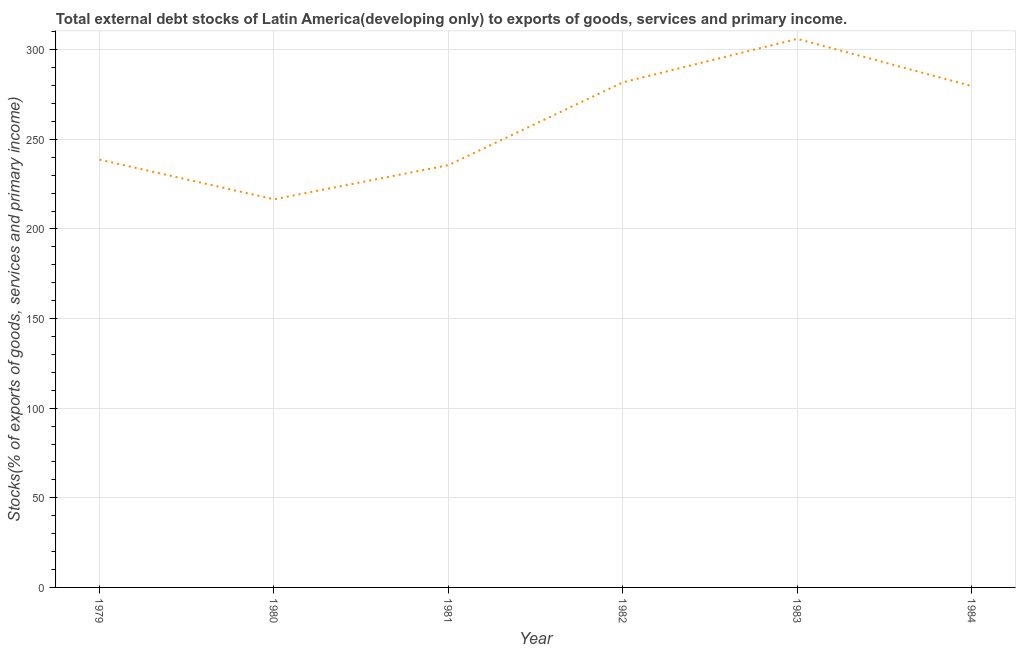What is the external debt stocks in 1981?
Offer a very short reply. 235.61. Across all years, what is the maximum external debt stocks?
Ensure brevity in your answer.  306.06. Across all years, what is the minimum external debt stocks?
Make the answer very short. 216.55. What is the sum of the external debt stocks?
Your answer should be very brief. 1558.36. What is the difference between the external debt stocks in 1980 and 1983?
Keep it short and to the point. -89.51. What is the average external debt stocks per year?
Your answer should be very brief. 259.73. What is the median external debt stocks?
Your response must be concise. 259.17. In how many years, is the external debt stocks greater than 60 %?
Keep it short and to the point. 6. What is the ratio of the external debt stocks in 1982 to that in 1984?
Offer a terse response. 1.01. Is the difference between the external debt stocks in 1983 and 1984 greater than the difference between any two years?
Offer a very short reply. No. What is the difference between the highest and the second highest external debt stocks?
Offer a terse response. 24.26. Is the sum of the external debt stocks in 1979 and 1984 greater than the maximum external debt stocks across all years?
Provide a short and direct response. Yes. What is the difference between the highest and the lowest external debt stocks?
Provide a succinct answer. 89.51. Does the external debt stocks monotonically increase over the years?
Make the answer very short. No. What is the difference between two consecutive major ticks on the Y-axis?
Offer a terse response. 50. Does the graph contain grids?
Offer a very short reply. Yes. What is the title of the graph?
Make the answer very short. Total external debt stocks of Latin America(developing only) to exports of goods, services and primary income. What is the label or title of the X-axis?
Give a very brief answer. Year. What is the label or title of the Y-axis?
Your response must be concise. Stocks(% of exports of goods, services and primary income). What is the Stocks(% of exports of goods, services and primary income) in 1979?
Give a very brief answer. 238.68. What is the Stocks(% of exports of goods, services and primary income) of 1980?
Your answer should be compact. 216.55. What is the Stocks(% of exports of goods, services and primary income) in 1981?
Your response must be concise. 235.61. What is the Stocks(% of exports of goods, services and primary income) of 1982?
Keep it short and to the point. 281.8. What is the Stocks(% of exports of goods, services and primary income) in 1983?
Provide a short and direct response. 306.06. What is the Stocks(% of exports of goods, services and primary income) of 1984?
Your response must be concise. 279.67. What is the difference between the Stocks(% of exports of goods, services and primary income) in 1979 and 1980?
Provide a succinct answer. 22.13. What is the difference between the Stocks(% of exports of goods, services and primary income) in 1979 and 1981?
Your answer should be compact. 3.08. What is the difference between the Stocks(% of exports of goods, services and primary income) in 1979 and 1982?
Your answer should be very brief. -43.12. What is the difference between the Stocks(% of exports of goods, services and primary income) in 1979 and 1983?
Make the answer very short. -67.38. What is the difference between the Stocks(% of exports of goods, services and primary income) in 1979 and 1984?
Your response must be concise. -40.99. What is the difference between the Stocks(% of exports of goods, services and primary income) in 1980 and 1981?
Provide a short and direct response. -19.06. What is the difference between the Stocks(% of exports of goods, services and primary income) in 1980 and 1982?
Your answer should be compact. -65.25. What is the difference between the Stocks(% of exports of goods, services and primary income) in 1980 and 1983?
Make the answer very short. -89.51. What is the difference between the Stocks(% of exports of goods, services and primary income) in 1980 and 1984?
Your answer should be very brief. -63.12. What is the difference between the Stocks(% of exports of goods, services and primary income) in 1981 and 1982?
Offer a very short reply. -46.19. What is the difference between the Stocks(% of exports of goods, services and primary income) in 1981 and 1983?
Your answer should be compact. -70.45. What is the difference between the Stocks(% of exports of goods, services and primary income) in 1981 and 1984?
Ensure brevity in your answer.  -44.06. What is the difference between the Stocks(% of exports of goods, services and primary income) in 1982 and 1983?
Give a very brief answer. -24.26. What is the difference between the Stocks(% of exports of goods, services and primary income) in 1982 and 1984?
Offer a very short reply. 2.13. What is the difference between the Stocks(% of exports of goods, services and primary income) in 1983 and 1984?
Offer a terse response. 26.39. What is the ratio of the Stocks(% of exports of goods, services and primary income) in 1979 to that in 1980?
Your answer should be very brief. 1.1. What is the ratio of the Stocks(% of exports of goods, services and primary income) in 1979 to that in 1982?
Your response must be concise. 0.85. What is the ratio of the Stocks(% of exports of goods, services and primary income) in 1979 to that in 1983?
Offer a terse response. 0.78. What is the ratio of the Stocks(% of exports of goods, services and primary income) in 1979 to that in 1984?
Provide a short and direct response. 0.85. What is the ratio of the Stocks(% of exports of goods, services and primary income) in 1980 to that in 1981?
Offer a terse response. 0.92. What is the ratio of the Stocks(% of exports of goods, services and primary income) in 1980 to that in 1982?
Offer a very short reply. 0.77. What is the ratio of the Stocks(% of exports of goods, services and primary income) in 1980 to that in 1983?
Ensure brevity in your answer.  0.71. What is the ratio of the Stocks(% of exports of goods, services and primary income) in 1980 to that in 1984?
Ensure brevity in your answer.  0.77. What is the ratio of the Stocks(% of exports of goods, services and primary income) in 1981 to that in 1982?
Your answer should be compact. 0.84. What is the ratio of the Stocks(% of exports of goods, services and primary income) in 1981 to that in 1983?
Provide a short and direct response. 0.77. What is the ratio of the Stocks(% of exports of goods, services and primary income) in 1981 to that in 1984?
Give a very brief answer. 0.84. What is the ratio of the Stocks(% of exports of goods, services and primary income) in 1982 to that in 1983?
Keep it short and to the point. 0.92. What is the ratio of the Stocks(% of exports of goods, services and primary income) in 1983 to that in 1984?
Ensure brevity in your answer.  1.09. 